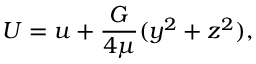<formula> <loc_0><loc_0><loc_500><loc_500>U = u + { \frac { G } { 4 \mu } } ( y ^ { 2 } + z ^ { 2 } ) ,</formula> 